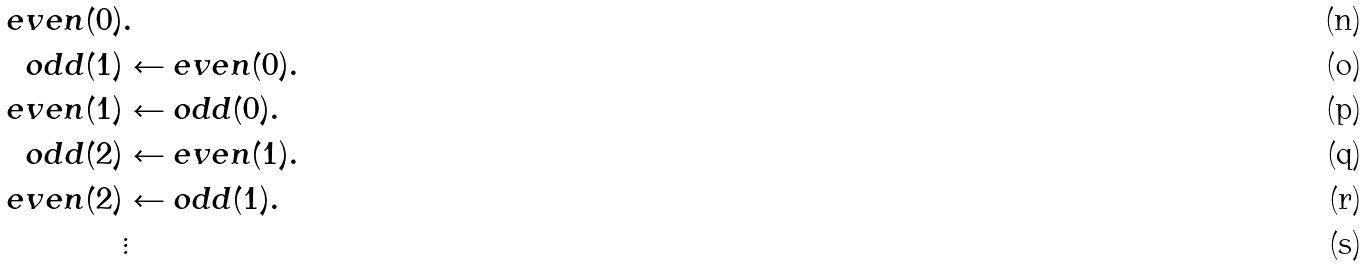<formula> <loc_0><loc_0><loc_500><loc_500>e v e n ( 0 ) & . \\ o d d ( 1 ) & \leftarrow e v e n ( 0 ) . \\ e v e n ( 1 ) & \leftarrow o d d ( 0 ) . \\ o d d ( 2 ) & \leftarrow e v e n ( 1 ) . \\ e v e n ( 2 ) & \leftarrow o d d ( 1 ) . \\ & \vdots</formula> 